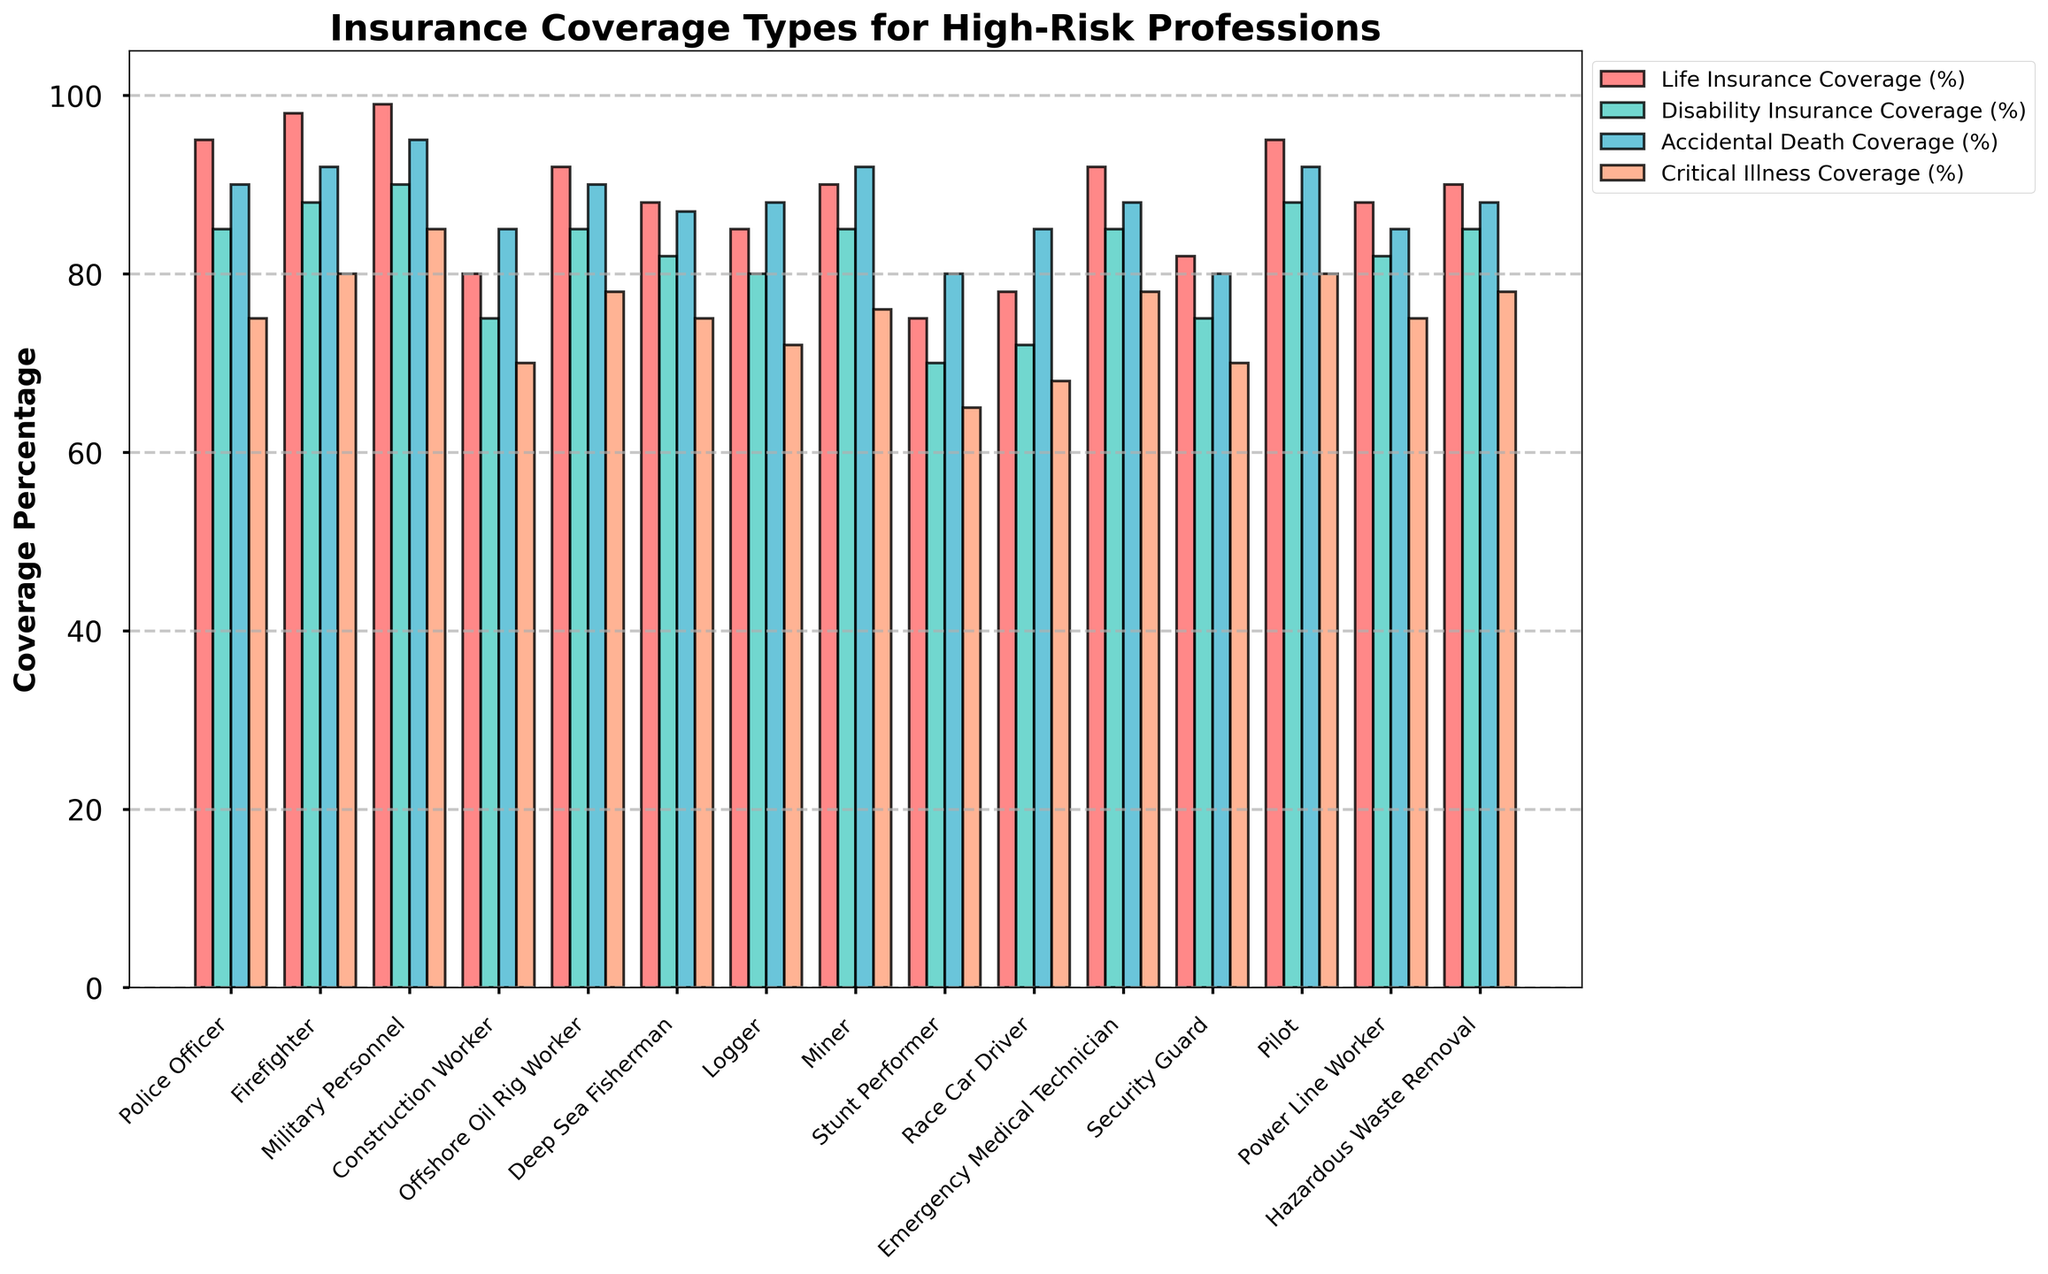Which profession has the highest life insurance coverage? Refer to the bars for life insurance coverage and identify the highest one. The bar for Military Personnel is the tallest.
Answer: Military Personnel Which profession has the lowest critical illness coverage? Observe the bars for critical illness coverage and find the shortest one. The bar for Stunt Performer is the shortest.
Answer: Stunt Performer What's the difference in accidental death coverage between Firefighter and Logger? Find the heights of the bars for accidental death coverage for Firefighter and Logger, then subtract the smaller from the larger. Firefighter: 92%, Logger: 88%, so 92 - 88 = 4.
Answer: 4% Which two professions have identical life insurance coverage? Identify the bars for life insurance coverage with the same height. Police Officer and Pilot both have the same height.
Answer: Police Officer and Pilot Among all professions, which one has the closest values in percentage across all four insurance types? Compare the coverage bars for each profession and identify the one with the most similar heights. Offshore Oil Rig Worker has 92% for life insurance, 85% for disability, 90% for accidental death, and 78% for critical illness which are quite close.
Answer: Offshore Oil Rig Worker How much higher is the life insurance coverage for Military Personnel compared to Stunt Performer? Find the heights of the bars for life insurance coverage for Military Personnel and Stunt Performer, then subtract the smaller from the larger. Military Personnel: 99%, Stunt Performer: 75%, so 99 - 75 = 24.
Answer: 24% Which coverage type tends to be the highest across most professions? Observe the general trend of the bar heights for each coverage type across all professions. Life insurance coverage bars generally appear to be the highest.
Answer: Life Insurance Coverage Find the average critical illness coverage percentage for Firefighter, Military Personnel, and Pilot. Sum the critical illness coverage percentages for Firefighter (80%), Military Personnel (85%), and Pilot (80%), then divide by 3. (80 + 85 + 80) / 3 = 81.66.
Answer: 81.67% Is disability insurance coverage for Logger greater than that for Race Car Driver? Compare the heights of the bars for disability insurance coverage for Logger and Race Car Driver. Logger: 80%, Race Car Driver: 72%. Logger's bar is taller.
Answer: Yes What’s the total life insurance coverage percentage for all professions combined? Add up the life insurance coverage percentages for all professions. 95 + 98 + 99 + 80 + 92 + 88 + 85 + 90 + 75 + 78 + 92 + 82 + 95 + 88 + 90 = 1227.
Answer: 1227% 